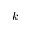<formula> <loc_0><loc_0><loc_500><loc_500>k</formula> 